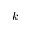<formula> <loc_0><loc_0><loc_500><loc_500>k</formula> 